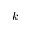<formula> <loc_0><loc_0><loc_500><loc_500>k</formula> 